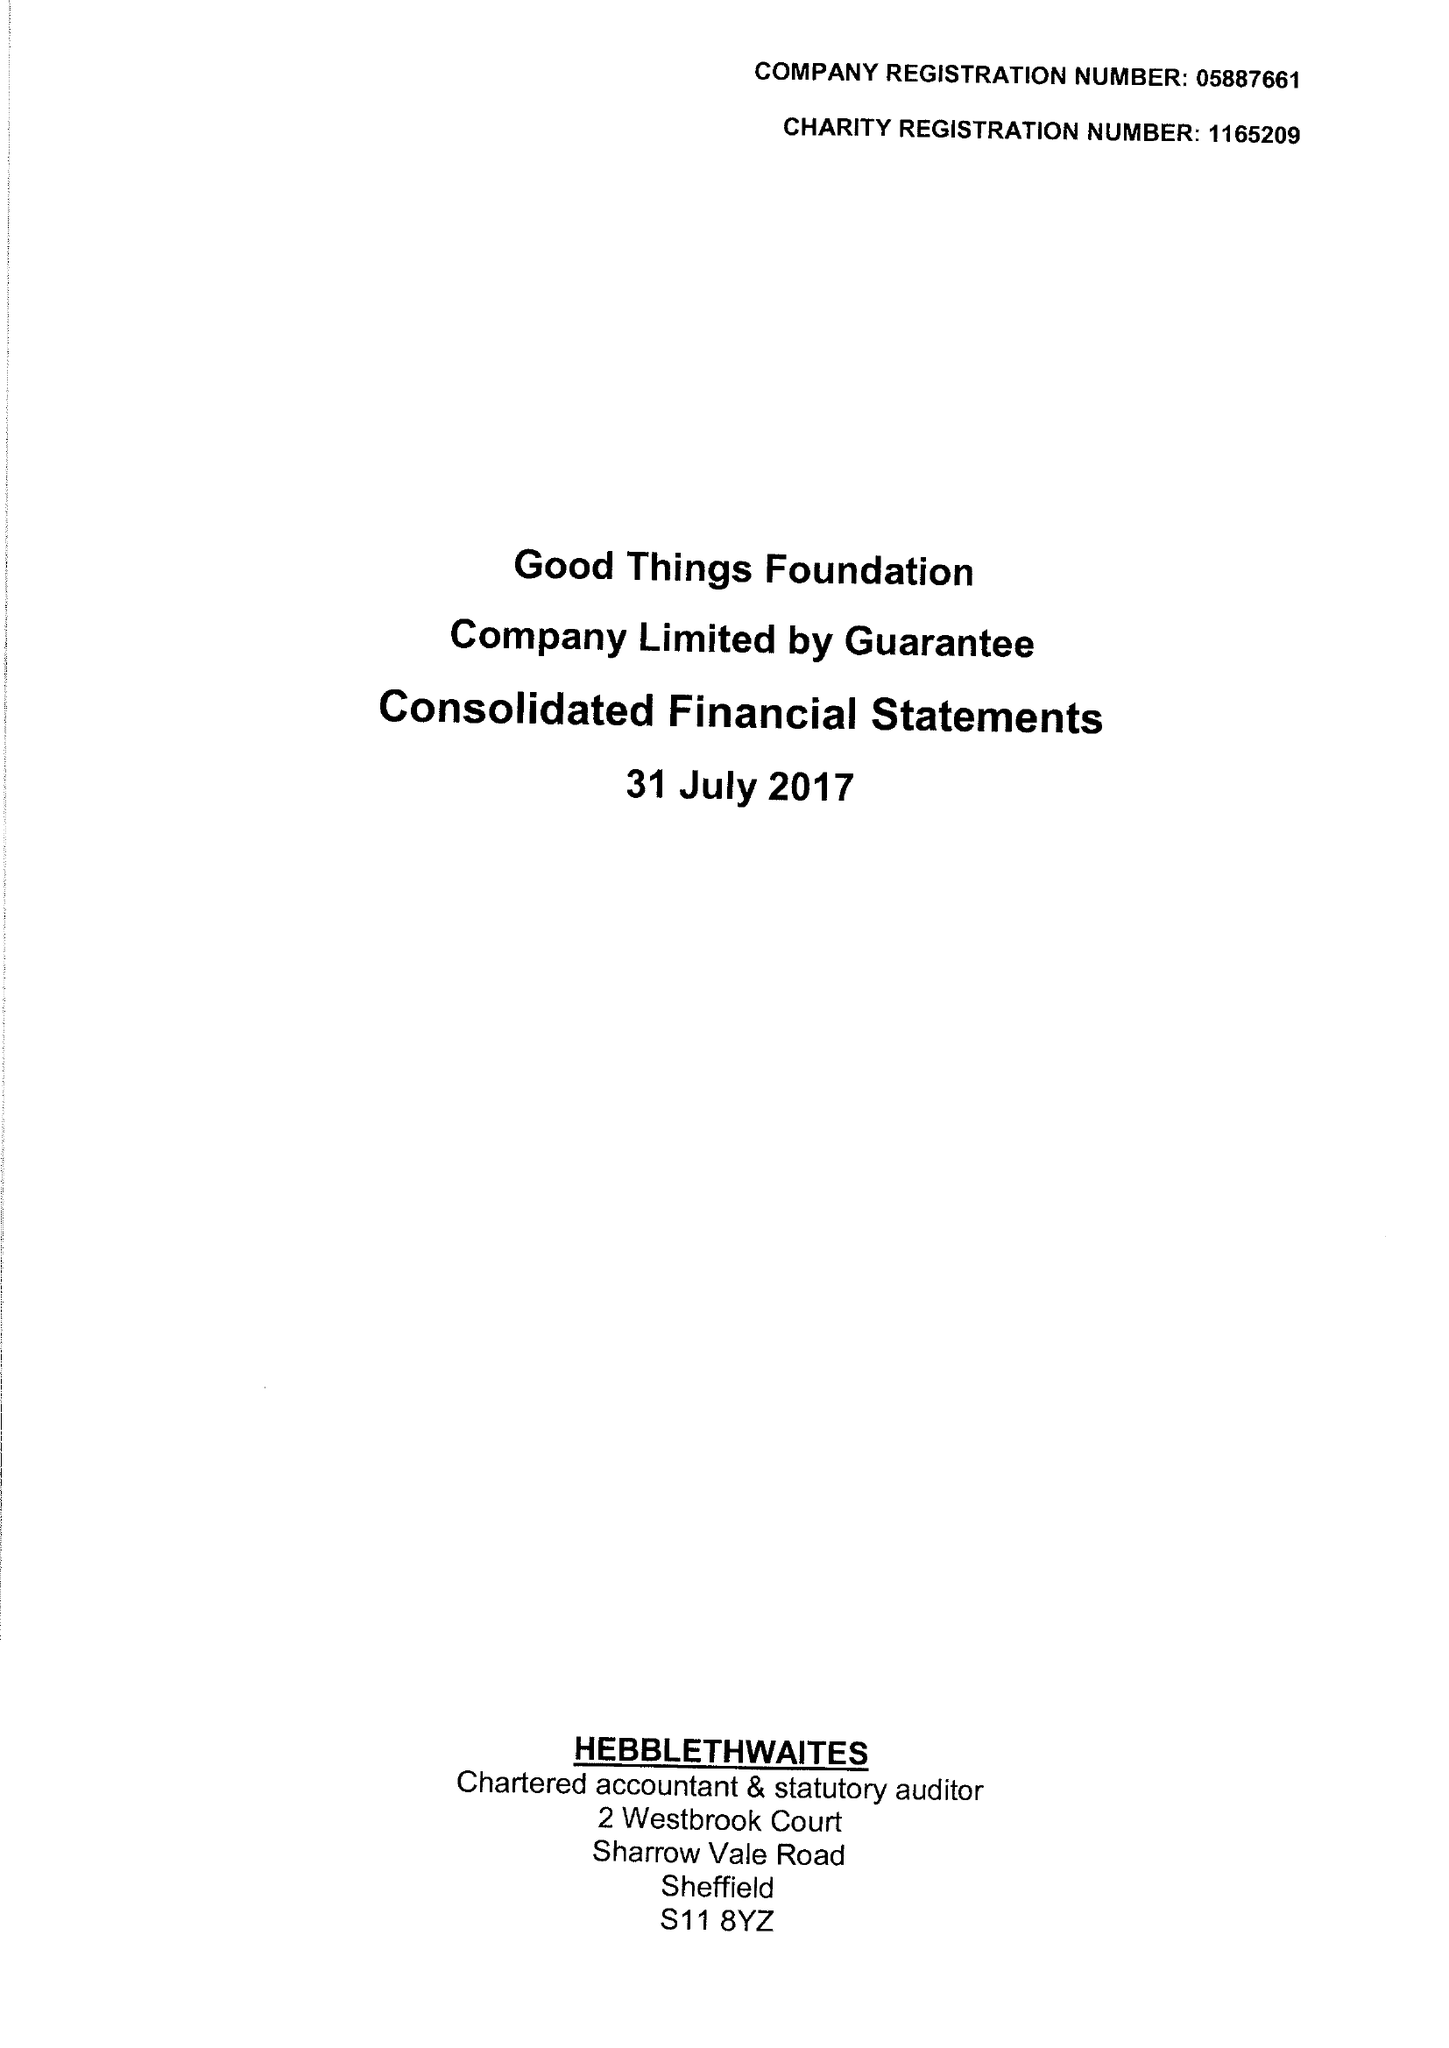What is the value for the report_date?
Answer the question using a single word or phrase. 2017-07-31 